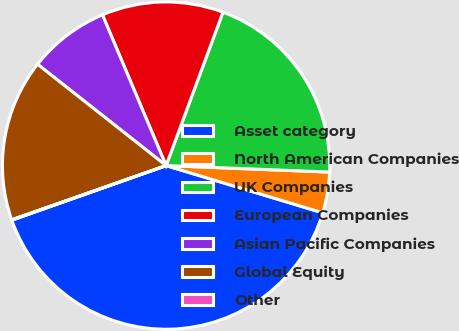Convert chart. <chart><loc_0><loc_0><loc_500><loc_500><pie_chart><fcel>Asset category<fcel>North American Companies<fcel>UK Companies<fcel>European Companies<fcel>Asian Pacific Companies<fcel>Global Equity<fcel>Other<nl><fcel>39.93%<fcel>4.03%<fcel>19.98%<fcel>12.01%<fcel>8.02%<fcel>16.0%<fcel>0.04%<nl></chart> 